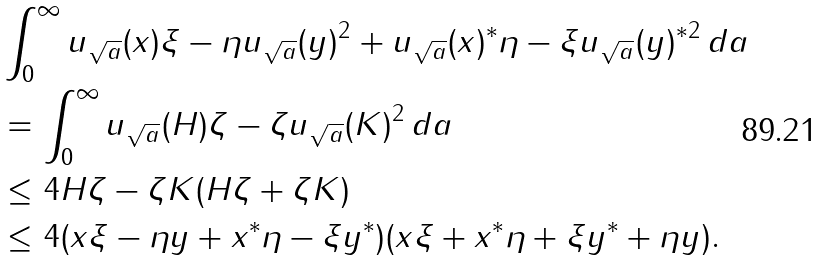<formula> <loc_0><loc_0><loc_500><loc_500>& \int _ { 0 } ^ { \infty } \| u _ { \sqrt { a } } ( x ) \xi - \eta u _ { \sqrt { a } } ( y ) \| ^ { 2 } + \| u _ { \sqrt { a } } ( x ) ^ { * } \eta - \xi u _ { \sqrt { a } } ( y ) ^ { * } \| ^ { 2 } \, d a \\ & = \int _ { 0 } ^ { \infty } \| u _ { \sqrt { a } } ( H ) \zeta - \zeta u _ { \sqrt { a } } ( K ) \| ^ { 2 } \, d a \\ & \leq 4 \| H \zeta - \zeta K \| ( \| H \zeta \| + \| \zeta K \| ) \\ & \leq 4 ( \| x \xi - \eta y \| + \| x ^ { * } \eta - \xi y ^ { * } \| ) ( \| x \xi \| + \| x ^ { * } \eta \| + \| \xi y ^ { * } \| + \| \eta y \| ) .</formula> 